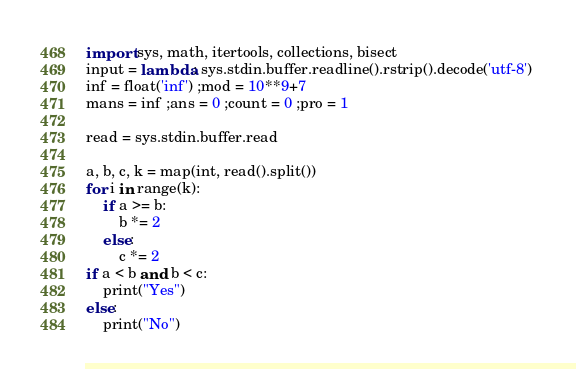<code> <loc_0><loc_0><loc_500><loc_500><_Python_>import sys, math, itertools, collections, bisect
input = lambda: sys.stdin.buffer.readline().rstrip().decode('utf-8') 
inf = float('inf') ;mod = 10**9+7 
mans = inf ;ans = 0 ;count = 0 ;pro = 1

read = sys.stdin.buffer.read

a, b, c, k = map(int, read().split())
for i in range(k):
    if a >= b:
        b *= 2
    else:
        c *= 2
if a < b and b < c:
    print("Yes")
else:
    print("No")</code> 